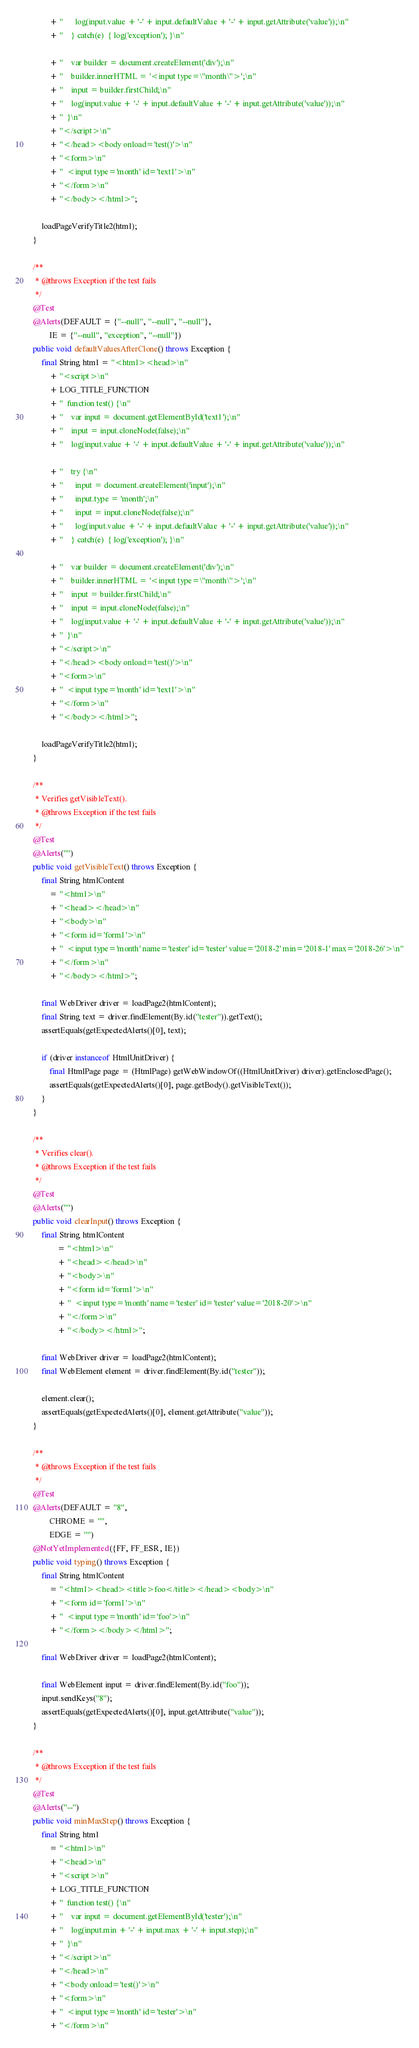Convert code to text. <code><loc_0><loc_0><loc_500><loc_500><_Java_>            + "      log(input.value + '-' + input.defaultValue + '-' + input.getAttribute('value'));\n"
            + "    } catch(e)  { log('exception'); }\n"

            + "    var builder = document.createElement('div');\n"
            + "    builder.innerHTML = '<input type=\"month\">';\n"
            + "    input = builder.firstChild;\n"
            + "    log(input.value + '-' + input.defaultValue + '-' + input.getAttribute('value'));\n"
            + "  }\n"
            + "</script>\n"
            + "</head><body onload='test()'>\n"
            + "<form>\n"
            + "  <input type='month' id='text1'>\n"
            + "</form>\n"
            + "</body></html>";

        loadPageVerifyTitle2(html);
    }

    /**
     * @throws Exception if the test fails
     */
    @Test
    @Alerts(DEFAULT = {"--null", "--null", "--null"},
            IE = {"--null", "exception", "--null"})
    public void defaultValuesAfterClone() throws Exception {
        final String html = "<html><head>\n"
            + "<script>\n"
            + LOG_TITLE_FUNCTION
            + "  function test() {\n"
            + "    var input = document.getElementById('text1');\n"
            + "    input = input.cloneNode(false);\n"
            + "    log(input.value + '-' + input.defaultValue + '-' + input.getAttribute('value'));\n"

            + "    try {\n"
            + "      input = document.createElement('input');\n"
            + "      input.type = 'month';\n"
            + "      input = input.cloneNode(false);\n"
            + "      log(input.value + '-' + input.defaultValue + '-' + input.getAttribute('value'));\n"
            + "    } catch(e)  { log('exception'); }\n"

            + "    var builder = document.createElement('div');\n"
            + "    builder.innerHTML = '<input type=\"month\">';\n"
            + "    input = builder.firstChild;\n"
            + "    input = input.cloneNode(false);\n"
            + "    log(input.value + '-' + input.defaultValue + '-' + input.getAttribute('value'));\n"
            + "  }\n"
            + "</script>\n"
            + "</head><body onload='test()'>\n"
            + "<form>\n"
            + "  <input type='month' id='text1'>\n"
            + "</form>\n"
            + "</body></html>";

        loadPageVerifyTitle2(html);
    }

    /**
     * Verifies getVisibleText().
     * @throws Exception if the test fails
     */
    @Test
    @Alerts("")
    public void getVisibleText() throws Exception {
        final String htmlContent
            = "<html>\n"
            + "<head></head>\n"
            + "<body>\n"
            + "<form id='form1'>\n"
            + "  <input type='month' name='tester' id='tester' value='2018-2' min='2018-1' max='2018-26'>\n"
            + "</form>\n"
            + "</body></html>";

        final WebDriver driver = loadPage2(htmlContent);
        final String text = driver.findElement(By.id("tester")).getText();
        assertEquals(getExpectedAlerts()[0], text);

        if (driver instanceof HtmlUnitDriver) {
            final HtmlPage page = (HtmlPage) getWebWindowOf((HtmlUnitDriver) driver).getEnclosedPage();
            assertEquals(getExpectedAlerts()[0], page.getBody().getVisibleText());
        }
    }

    /**
     * Verifies clear().
     * @throws Exception if the test fails
     */
    @Test
    @Alerts("")
    public void clearInput() throws Exception {
        final String htmlContent
                = "<html>\n"
                + "<head></head>\n"
                + "<body>\n"
                + "<form id='form1'>\n"
                + "  <input type='month' name='tester' id='tester' value='2018-20'>\n"
                + "</form>\n"
                + "</body></html>";

        final WebDriver driver = loadPage2(htmlContent);
        final WebElement element = driver.findElement(By.id("tester"));

        element.clear();
        assertEquals(getExpectedAlerts()[0], element.getAttribute("value"));
    }

    /**
     * @throws Exception if the test fails
     */
    @Test
    @Alerts(DEFAULT = "8",
            CHROME = "",
            EDGE = "")
    @NotYetImplemented({FF, FF_ESR, IE})
    public void typing() throws Exception {
        final String htmlContent
            = "<html><head><title>foo</title></head><body>\n"
            + "<form id='form1'>\n"
            + "  <input type='month' id='foo'>\n"
            + "</form></body></html>";

        final WebDriver driver = loadPage2(htmlContent);

        final WebElement input = driver.findElement(By.id("foo"));
        input.sendKeys("8");
        assertEquals(getExpectedAlerts()[0], input.getAttribute("value"));
    }

    /**
     * @throws Exception if the test fails
     */
    @Test
    @Alerts("--")
    public void minMaxStep() throws Exception {
        final String html
            = "<html>\n"
            + "<head>\n"
            + "<script>\n"
            + LOG_TITLE_FUNCTION
            + "  function test() {\n"
            + "    var input = document.getElementById('tester');\n"
            + "    log(input.min + '-' + input.max + '-' + input.step);\n"
            + "  }\n"
            + "</script>\n"
            + "</head>\n"
            + "<body onload='test()'>\n"
            + "<form>\n"
            + "  <input type='month' id='tester'>\n"
            + "</form>\n"</code> 